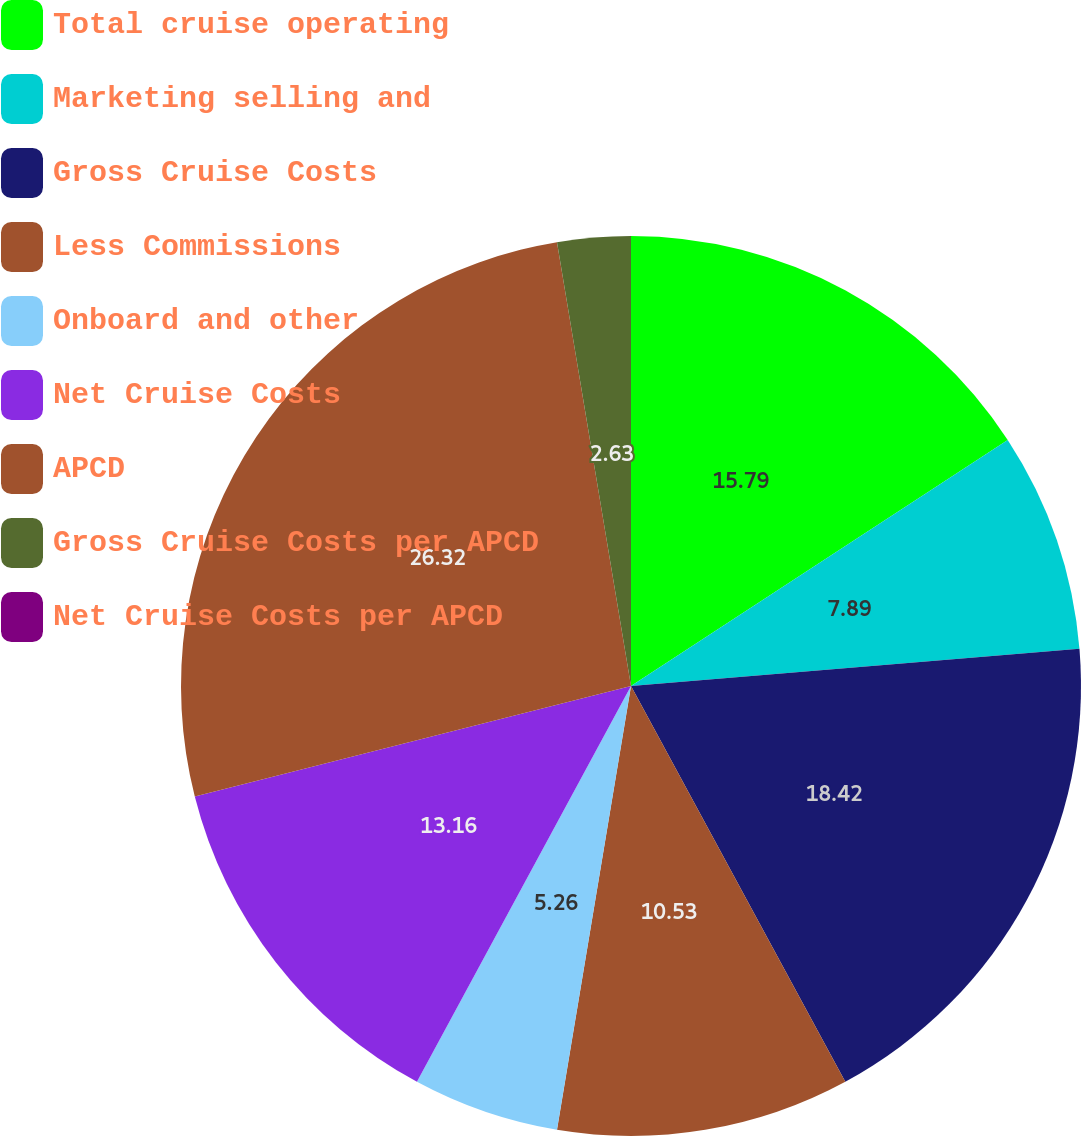Convert chart. <chart><loc_0><loc_0><loc_500><loc_500><pie_chart><fcel>Total cruise operating<fcel>Marketing selling and<fcel>Gross Cruise Costs<fcel>Less Commissions<fcel>Onboard and other<fcel>Net Cruise Costs<fcel>APCD<fcel>Gross Cruise Costs per APCD<fcel>Net Cruise Costs per APCD<nl><fcel>15.79%<fcel>7.89%<fcel>18.42%<fcel>10.53%<fcel>5.26%<fcel>13.16%<fcel>26.32%<fcel>2.63%<fcel>0.0%<nl></chart> 